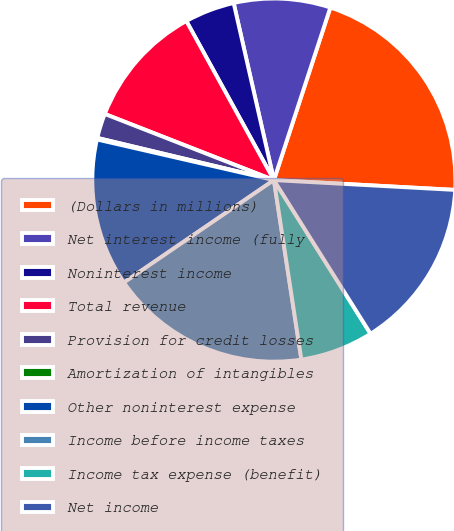Convert chart to OTSL. <chart><loc_0><loc_0><loc_500><loc_500><pie_chart><fcel>(Dollars in millions)<fcel>Net interest income (fully<fcel>Noninterest income<fcel>Total revenue<fcel>Provision for credit losses<fcel>Amortization of intangibles<fcel>Other noninterest expense<fcel>Income before income taxes<fcel>Income tax expense (benefit)<fcel>Net income<nl><fcel>20.83%<fcel>8.59%<fcel>4.45%<fcel>11.06%<fcel>2.2%<fcel>0.14%<fcel>13.13%<fcel>17.88%<fcel>6.52%<fcel>15.2%<nl></chart> 